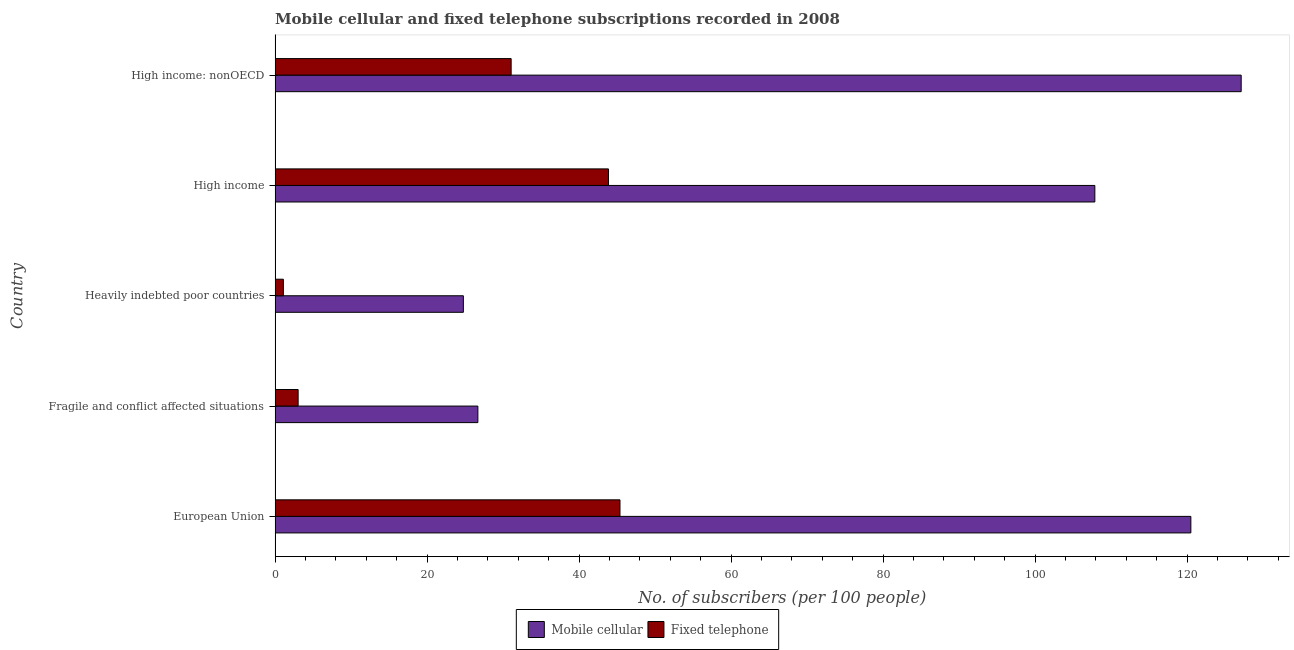How many bars are there on the 5th tick from the top?
Offer a terse response. 2. How many bars are there on the 2nd tick from the bottom?
Your answer should be very brief. 2. What is the label of the 1st group of bars from the top?
Offer a terse response. High income: nonOECD. In how many cases, is the number of bars for a given country not equal to the number of legend labels?
Provide a succinct answer. 0. What is the number of mobile cellular subscribers in High income: nonOECD?
Provide a short and direct response. 127.11. Across all countries, what is the maximum number of fixed telephone subscribers?
Your answer should be very brief. 45.38. Across all countries, what is the minimum number of mobile cellular subscribers?
Ensure brevity in your answer.  24.77. In which country was the number of mobile cellular subscribers minimum?
Offer a very short reply. Heavily indebted poor countries. What is the total number of fixed telephone subscribers in the graph?
Make the answer very short. 124.42. What is the difference between the number of mobile cellular subscribers in European Union and that in Fragile and conflict affected situations?
Offer a very short reply. 93.8. What is the difference between the number of mobile cellular subscribers in High income and the number of fixed telephone subscribers in Fragile and conflict affected situations?
Keep it short and to the point. 104.82. What is the average number of fixed telephone subscribers per country?
Provide a succinct answer. 24.88. What is the difference between the number of mobile cellular subscribers and number of fixed telephone subscribers in Fragile and conflict affected situations?
Provide a short and direct response. 23.65. In how many countries, is the number of fixed telephone subscribers greater than 64 ?
Your response must be concise. 0. What is the ratio of the number of fixed telephone subscribers in European Union to that in High income: nonOECD?
Provide a short and direct response. 1.46. Is the number of mobile cellular subscribers in Heavily indebted poor countries less than that in High income?
Offer a very short reply. Yes. What is the difference between the highest and the second highest number of fixed telephone subscribers?
Provide a short and direct response. 1.52. What is the difference between the highest and the lowest number of fixed telephone subscribers?
Your answer should be very brief. 44.29. In how many countries, is the number of mobile cellular subscribers greater than the average number of mobile cellular subscribers taken over all countries?
Offer a very short reply. 3. What does the 2nd bar from the top in High income represents?
Offer a very short reply. Mobile cellular. What does the 2nd bar from the bottom in High income represents?
Make the answer very short. Fixed telephone. How many bars are there?
Your answer should be very brief. 10. Are all the bars in the graph horizontal?
Your answer should be very brief. Yes. How many countries are there in the graph?
Make the answer very short. 5. What is the difference between two consecutive major ticks on the X-axis?
Provide a succinct answer. 20. Does the graph contain any zero values?
Your response must be concise. No. Does the graph contain grids?
Give a very brief answer. No. How many legend labels are there?
Your answer should be very brief. 2. How are the legend labels stacked?
Offer a very short reply. Horizontal. What is the title of the graph?
Your response must be concise. Mobile cellular and fixed telephone subscriptions recorded in 2008. Does "Pregnant women" appear as one of the legend labels in the graph?
Offer a terse response. No. What is the label or title of the X-axis?
Keep it short and to the point. No. of subscribers (per 100 people). What is the label or title of the Y-axis?
Offer a very short reply. Country. What is the No. of subscribers (per 100 people) in Mobile cellular in European Union?
Make the answer very short. 120.48. What is the No. of subscribers (per 100 people) in Fixed telephone in European Union?
Offer a terse response. 45.38. What is the No. of subscribers (per 100 people) of Mobile cellular in Fragile and conflict affected situations?
Ensure brevity in your answer.  26.68. What is the No. of subscribers (per 100 people) in Fixed telephone in Fragile and conflict affected situations?
Offer a terse response. 3.03. What is the No. of subscribers (per 100 people) in Mobile cellular in Heavily indebted poor countries?
Your answer should be very brief. 24.77. What is the No. of subscribers (per 100 people) of Fixed telephone in Heavily indebted poor countries?
Offer a terse response. 1.09. What is the No. of subscribers (per 100 people) of Mobile cellular in High income?
Your response must be concise. 107.85. What is the No. of subscribers (per 100 people) in Fixed telephone in High income?
Keep it short and to the point. 43.86. What is the No. of subscribers (per 100 people) of Mobile cellular in High income: nonOECD?
Your response must be concise. 127.11. What is the No. of subscribers (per 100 people) in Fixed telephone in High income: nonOECD?
Make the answer very short. 31.06. Across all countries, what is the maximum No. of subscribers (per 100 people) of Mobile cellular?
Your answer should be compact. 127.11. Across all countries, what is the maximum No. of subscribers (per 100 people) in Fixed telephone?
Provide a short and direct response. 45.38. Across all countries, what is the minimum No. of subscribers (per 100 people) of Mobile cellular?
Your response must be concise. 24.77. Across all countries, what is the minimum No. of subscribers (per 100 people) of Fixed telephone?
Your answer should be compact. 1.09. What is the total No. of subscribers (per 100 people) in Mobile cellular in the graph?
Offer a very short reply. 406.89. What is the total No. of subscribers (per 100 people) of Fixed telephone in the graph?
Offer a very short reply. 124.42. What is the difference between the No. of subscribers (per 100 people) in Mobile cellular in European Union and that in Fragile and conflict affected situations?
Your response must be concise. 93.8. What is the difference between the No. of subscribers (per 100 people) of Fixed telephone in European Union and that in Fragile and conflict affected situations?
Ensure brevity in your answer.  42.34. What is the difference between the No. of subscribers (per 100 people) in Mobile cellular in European Union and that in Heavily indebted poor countries?
Your response must be concise. 95.71. What is the difference between the No. of subscribers (per 100 people) in Fixed telephone in European Union and that in Heavily indebted poor countries?
Offer a very short reply. 44.29. What is the difference between the No. of subscribers (per 100 people) in Mobile cellular in European Union and that in High income?
Offer a very short reply. 12.63. What is the difference between the No. of subscribers (per 100 people) in Fixed telephone in European Union and that in High income?
Ensure brevity in your answer.  1.52. What is the difference between the No. of subscribers (per 100 people) in Mobile cellular in European Union and that in High income: nonOECD?
Provide a short and direct response. -6.62. What is the difference between the No. of subscribers (per 100 people) of Fixed telephone in European Union and that in High income: nonOECD?
Your answer should be compact. 14.32. What is the difference between the No. of subscribers (per 100 people) of Mobile cellular in Fragile and conflict affected situations and that in Heavily indebted poor countries?
Give a very brief answer. 1.91. What is the difference between the No. of subscribers (per 100 people) in Fixed telephone in Fragile and conflict affected situations and that in Heavily indebted poor countries?
Give a very brief answer. 1.94. What is the difference between the No. of subscribers (per 100 people) of Mobile cellular in Fragile and conflict affected situations and that in High income?
Keep it short and to the point. -81.17. What is the difference between the No. of subscribers (per 100 people) in Fixed telephone in Fragile and conflict affected situations and that in High income?
Provide a short and direct response. -40.83. What is the difference between the No. of subscribers (per 100 people) in Mobile cellular in Fragile and conflict affected situations and that in High income: nonOECD?
Make the answer very short. -100.42. What is the difference between the No. of subscribers (per 100 people) in Fixed telephone in Fragile and conflict affected situations and that in High income: nonOECD?
Make the answer very short. -28.02. What is the difference between the No. of subscribers (per 100 people) of Mobile cellular in Heavily indebted poor countries and that in High income?
Your response must be concise. -83.08. What is the difference between the No. of subscribers (per 100 people) of Fixed telephone in Heavily indebted poor countries and that in High income?
Your answer should be compact. -42.77. What is the difference between the No. of subscribers (per 100 people) in Mobile cellular in Heavily indebted poor countries and that in High income: nonOECD?
Offer a very short reply. -102.33. What is the difference between the No. of subscribers (per 100 people) of Fixed telephone in Heavily indebted poor countries and that in High income: nonOECD?
Your answer should be very brief. -29.97. What is the difference between the No. of subscribers (per 100 people) of Mobile cellular in High income and that in High income: nonOECD?
Offer a very short reply. -19.25. What is the difference between the No. of subscribers (per 100 people) in Fixed telephone in High income and that in High income: nonOECD?
Your answer should be very brief. 12.8. What is the difference between the No. of subscribers (per 100 people) in Mobile cellular in European Union and the No. of subscribers (per 100 people) in Fixed telephone in Fragile and conflict affected situations?
Offer a terse response. 117.45. What is the difference between the No. of subscribers (per 100 people) of Mobile cellular in European Union and the No. of subscribers (per 100 people) of Fixed telephone in Heavily indebted poor countries?
Ensure brevity in your answer.  119.39. What is the difference between the No. of subscribers (per 100 people) of Mobile cellular in European Union and the No. of subscribers (per 100 people) of Fixed telephone in High income?
Give a very brief answer. 76.62. What is the difference between the No. of subscribers (per 100 people) in Mobile cellular in European Union and the No. of subscribers (per 100 people) in Fixed telephone in High income: nonOECD?
Provide a short and direct response. 89.43. What is the difference between the No. of subscribers (per 100 people) in Mobile cellular in Fragile and conflict affected situations and the No. of subscribers (per 100 people) in Fixed telephone in Heavily indebted poor countries?
Your response must be concise. 25.59. What is the difference between the No. of subscribers (per 100 people) in Mobile cellular in Fragile and conflict affected situations and the No. of subscribers (per 100 people) in Fixed telephone in High income?
Your answer should be compact. -17.18. What is the difference between the No. of subscribers (per 100 people) in Mobile cellular in Fragile and conflict affected situations and the No. of subscribers (per 100 people) in Fixed telephone in High income: nonOECD?
Provide a succinct answer. -4.38. What is the difference between the No. of subscribers (per 100 people) in Mobile cellular in Heavily indebted poor countries and the No. of subscribers (per 100 people) in Fixed telephone in High income?
Give a very brief answer. -19.09. What is the difference between the No. of subscribers (per 100 people) in Mobile cellular in Heavily indebted poor countries and the No. of subscribers (per 100 people) in Fixed telephone in High income: nonOECD?
Offer a very short reply. -6.29. What is the difference between the No. of subscribers (per 100 people) in Mobile cellular in High income and the No. of subscribers (per 100 people) in Fixed telephone in High income: nonOECD?
Offer a very short reply. 76.8. What is the average No. of subscribers (per 100 people) in Mobile cellular per country?
Make the answer very short. 81.38. What is the average No. of subscribers (per 100 people) of Fixed telephone per country?
Make the answer very short. 24.88. What is the difference between the No. of subscribers (per 100 people) in Mobile cellular and No. of subscribers (per 100 people) in Fixed telephone in European Union?
Your response must be concise. 75.11. What is the difference between the No. of subscribers (per 100 people) of Mobile cellular and No. of subscribers (per 100 people) of Fixed telephone in Fragile and conflict affected situations?
Your response must be concise. 23.65. What is the difference between the No. of subscribers (per 100 people) of Mobile cellular and No. of subscribers (per 100 people) of Fixed telephone in Heavily indebted poor countries?
Make the answer very short. 23.68. What is the difference between the No. of subscribers (per 100 people) of Mobile cellular and No. of subscribers (per 100 people) of Fixed telephone in High income?
Provide a succinct answer. 63.99. What is the difference between the No. of subscribers (per 100 people) of Mobile cellular and No. of subscribers (per 100 people) of Fixed telephone in High income: nonOECD?
Give a very brief answer. 96.05. What is the ratio of the No. of subscribers (per 100 people) of Mobile cellular in European Union to that in Fragile and conflict affected situations?
Provide a short and direct response. 4.52. What is the ratio of the No. of subscribers (per 100 people) in Fixed telephone in European Union to that in Fragile and conflict affected situations?
Your response must be concise. 14.96. What is the ratio of the No. of subscribers (per 100 people) in Mobile cellular in European Union to that in Heavily indebted poor countries?
Offer a very short reply. 4.86. What is the ratio of the No. of subscribers (per 100 people) of Fixed telephone in European Union to that in Heavily indebted poor countries?
Make the answer very short. 41.6. What is the ratio of the No. of subscribers (per 100 people) in Mobile cellular in European Union to that in High income?
Your answer should be compact. 1.12. What is the ratio of the No. of subscribers (per 100 people) of Fixed telephone in European Union to that in High income?
Offer a very short reply. 1.03. What is the ratio of the No. of subscribers (per 100 people) in Mobile cellular in European Union to that in High income: nonOECD?
Make the answer very short. 0.95. What is the ratio of the No. of subscribers (per 100 people) in Fixed telephone in European Union to that in High income: nonOECD?
Offer a terse response. 1.46. What is the ratio of the No. of subscribers (per 100 people) of Mobile cellular in Fragile and conflict affected situations to that in Heavily indebted poor countries?
Your response must be concise. 1.08. What is the ratio of the No. of subscribers (per 100 people) in Fixed telephone in Fragile and conflict affected situations to that in Heavily indebted poor countries?
Provide a short and direct response. 2.78. What is the ratio of the No. of subscribers (per 100 people) of Mobile cellular in Fragile and conflict affected situations to that in High income?
Offer a very short reply. 0.25. What is the ratio of the No. of subscribers (per 100 people) in Fixed telephone in Fragile and conflict affected situations to that in High income?
Your answer should be compact. 0.07. What is the ratio of the No. of subscribers (per 100 people) of Mobile cellular in Fragile and conflict affected situations to that in High income: nonOECD?
Provide a short and direct response. 0.21. What is the ratio of the No. of subscribers (per 100 people) of Fixed telephone in Fragile and conflict affected situations to that in High income: nonOECD?
Your answer should be very brief. 0.1. What is the ratio of the No. of subscribers (per 100 people) in Mobile cellular in Heavily indebted poor countries to that in High income?
Provide a succinct answer. 0.23. What is the ratio of the No. of subscribers (per 100 people) of Fixed telephone in Heavily indebted poor countries to that in High income?
Offer a very short reply. 0.02. What is the ratio of the No. of subscribers (per 100 people) in Mobile cellular in Heavily indebted poor countries to that in High income: nonOECD?
Make the answer very short. 0.19. What is the ratio of the No. of subscribers (per 100 people) of Fixed telephone in Heavily indebted poor countries to that in High income: nonOECD?
Provide a short and direct response. 0.04. What is the ratio of the No. of subscribers (per 100 people) of Mobile cellular in High income to that in High income: nonOECD?
Your answer should be very brief. 0.85. What is the ratio of the No. of subscribers (per 100 people) of Fixed telephone in High income to that in High income: nonOECD?
Ensure brevity in your answer.  1.41. What is the difference between the highest and the second highest No. of subscribers (per 100 people) of Mobile cellular?
Keep it short and to the point. 6.62. What is the difference between the highest and the second highest No. of subscribers (per 100 people) in Fixed telephone?
Keep it short and to the point. 1.52. What is the difference between the highest and the lowest No. of subscribers (per 100 people) in Mobile cellular?
Your answer should be compact. 102.33. What is the difference between the highest and the lowest No. of subscribers (per 100 people) of Fixed telephone?
Offer a terse response. 44.29. 